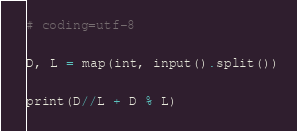Convert code to text. <code><loc_0><loc_0><loc_500><loc_500><_Python_># coding=utf-8

D, L = map(int, input().split())

print(D//L + D % L)

</code> 